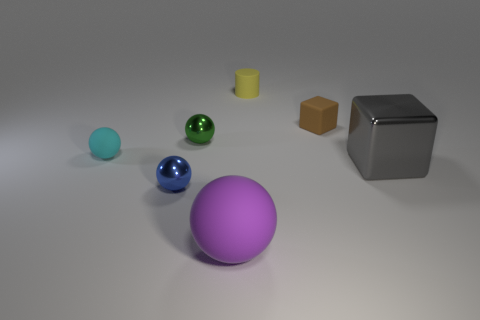Subtract 1 spheres. How many spheres are left? 3 Add 1 small cyan shiny spheres. How many objects exist? 8 Subtract all cylinders. How many objects are left? 6 Subtract 0 gray cylinders. How many objects are left? 7 Subtract all tiny purple metallic cubes. Subtract all large things. How many objects are left? 5 Add 2 tiny blocks. How many tiny blocks are left? 3 Add 3 tiny cyan spheres. How many tiny cyan spheres exist? 4 